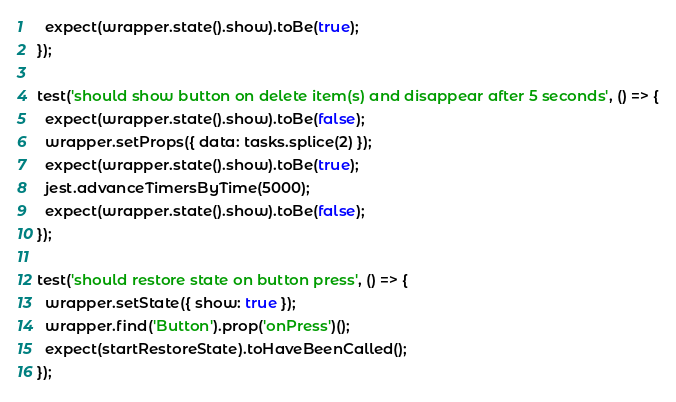Convert code to text. <code><loc_0><loc_0><loc_500><loc_500><_JavaScript_>  expect(wrapper.state().show).toBe(true);
});

test('should show button on delete item(s) and disappear after 5 seconds', () => {
  expect(wrapper.state().show).toBe(false);
  wrapper.setProps({ data: tasks.splice(2) });
  expect(wrapper.state().show).toBe(true);
  jest.advanceTimersByTime(5000);
  expect(wrapper.state().show).toBe(false);
});

test('should restore state on button press', () => {
  wrapper.setState({ show: true });
  wrapper.find('Button').prop('onPress')();
  expect(startRestoreState).toHaveBeenCalled();
});
</code> 